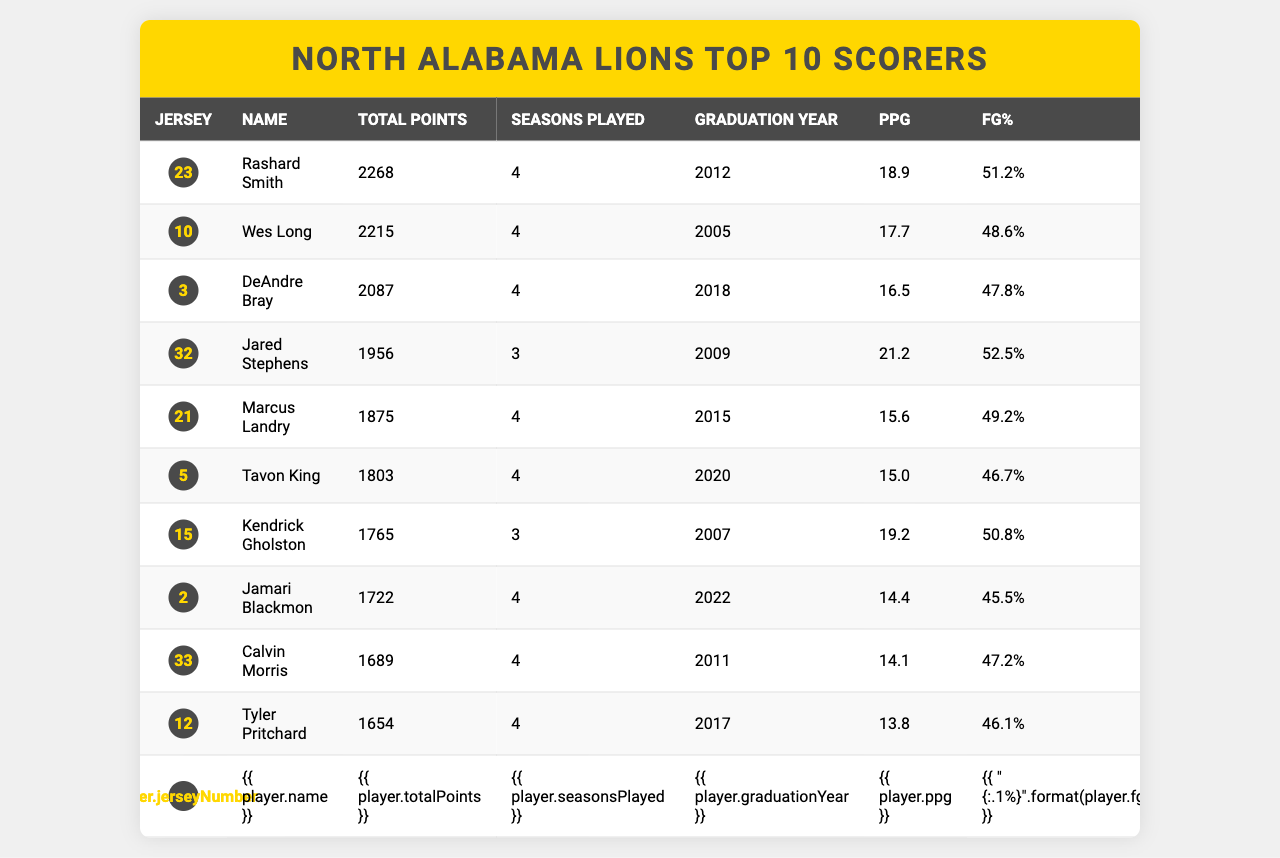What is Rashard Smith's total points? The table shows that Rashard Smith has a total of 2268 points.
Answer: 2268 How many seasons did Wes Long play? According to the table, Wes Long played for 4 seasons.
Answer: 4 Who had the highest points per game (PPG)? The table indicates that Jared Stephens had the highest PPG at 21.2.
Answer: Jared Stephens What is the total points scored by all players combined? The total points can be calculated by adding all the players' total points: 2268 + 2215 + 2087 + 1956 + 1875 + 1803 + 1765 + 1722 + 1689 + 1654 = 22,400.
Answer: 22400 Did Kendrick Gholston score more than Marcus Landry? By comparing the total points, Kendrick Gholston scored 1765 points while Marcus Landry scored 1875 points, so Gholston did not score more.
Answer: No What is the average total points scored by the players listed? The average total points can be calculated by dividing the total points (22,400) by the number of players (10): 22,400 / 10 = 2240.
Answer: 2240 Which player graduated in 2011? The table shows that Calvin Morris graduated in 2011.
Answer: Calvin Morris Is the field goal percentage (FG%) of Jamari Blackmon above 45%? Jamari Blackmon has a FG% of 45.5%, which is above 45%.
Answer: Yes What is the difference in total points between Rashard Smith and DeAndre Bray? Rashard Smith has 2268 points and DeAndre Bray has 2087 points. The difference is 2268 - 2087 = 181.
Answer: 181 How many players scored less than 1800 total points? From the table, the players with less than 1800 points are Jamari Blackmon, Calvin Morris, and Tyler Pritchard, totaling 3 players.
Answer: 3 